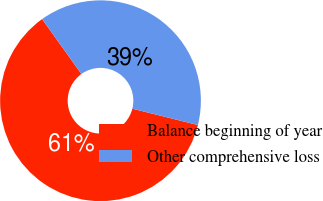Convert chart to OTSL. <chart><loc_0><loc_0><loc_500><loc_500><pie_chart><fcel>Balance beginning of year<fcel>Other comprehensive loss<nl><fcel>61.23%<fcel>38.77%<nl></chart> 